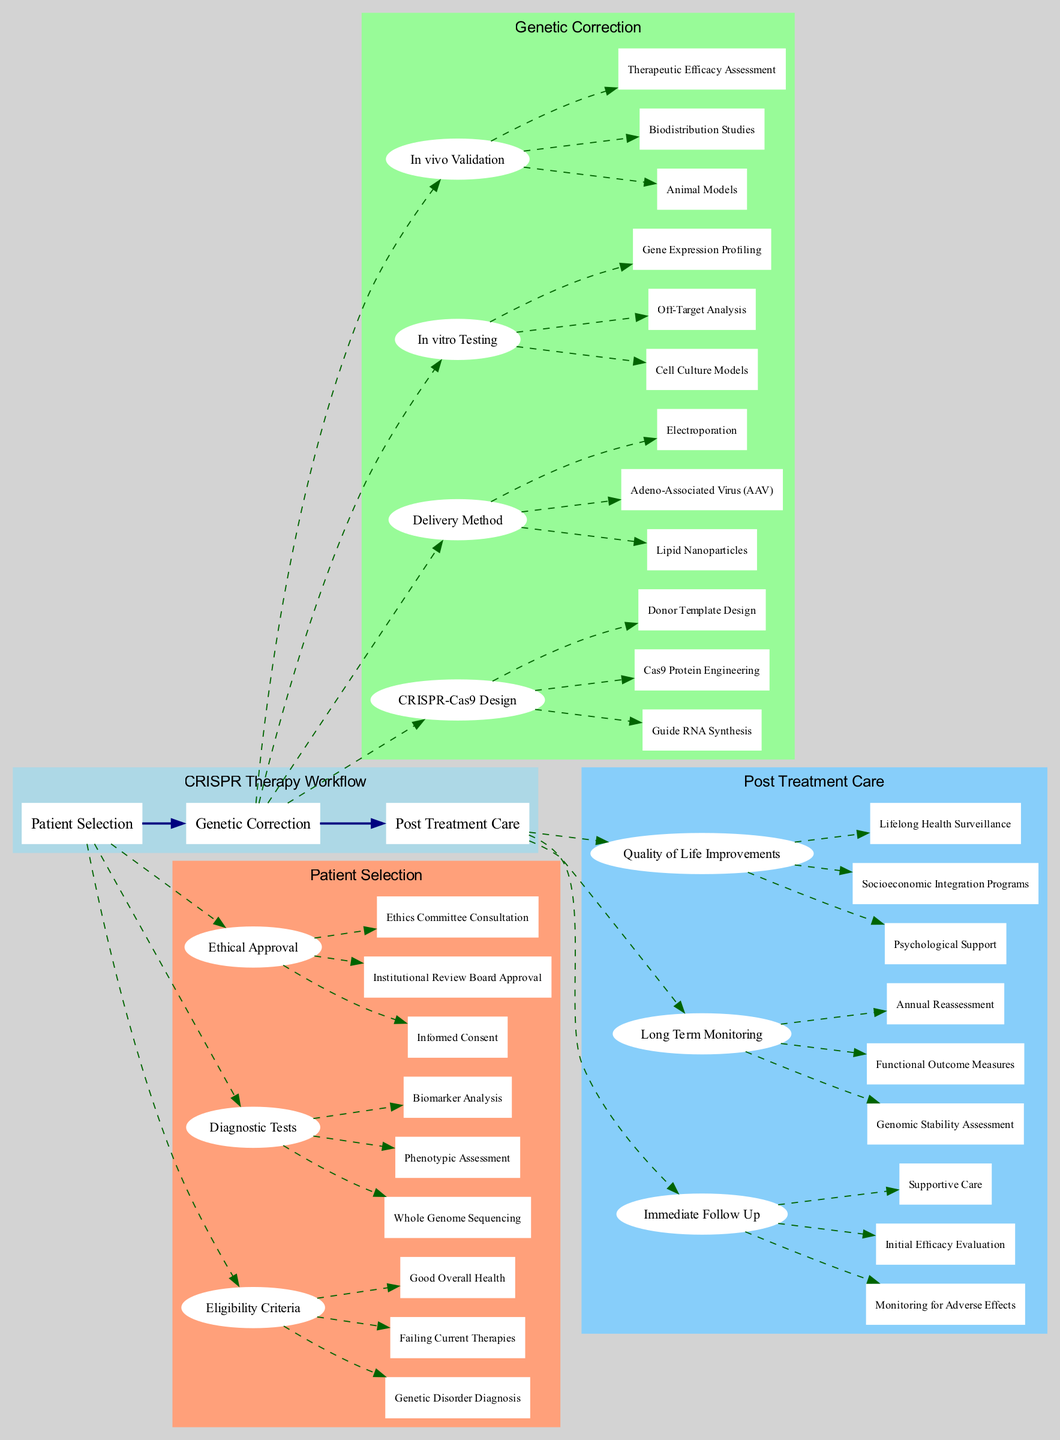What are the three eligibility criteria for patient selection? The diagram lists three eligibility criteria under Patient Selection: Genetic Disorder Diagnosis, Failing Current Therapies, and Good Overall Health.
Answer: Genetic Disorder Diagnosis, Failing Current Therapies, Good Overall Health How many delivery methods are there for genetic correction? There are three delivery methods listed under Genetic Correction: Lipid Nanoparticles, Adeno-Associated Virus, and Electroporation, making a total of three.
Answer: 3 What is the first item in post-treatment care? The diagram shows Immediate Follow-Up as the first category under Post Treatment Care, and the first item listed is Monitoring for Adverse Effects.
Answer: Monitoring for Adverse Effects What is the relationship between Ethical Approval and Patient Selection? The diagram clearly indicates that Ethical Approval is a sub-stage of Patient Selection, meaning that Ethical Approval is necessary for a patient to be selected for CRISPR therapy.
Answer: Ethical Approval is a sub-stage of Patient Selection What needs to be assessed in long-term monitoring? The diagram outlines Long Term Monitoring, which includes three aspects: Genomic Stability Assessment, Functional Outcome Measures, and Annual Reassessment.
Answer: Genomic Stability Assessment, Functional Outcome Measures, Annual Reassessment What are the two forms of in vivo validation mentioned? The diagram presents In vivo Validation as having three components; two of them are Animal Models and Therapeutic Efficacy Assessment.
Answer: Animal Models, Therapeutic Efficacy Assessment Which stage comes after genetic correction in the workflow? According to the flow of the diagram, Post Treatment Care follows after the Genetic Correction stage.
Answer: Post Treatment Care What is the main purpose of the CRISPR Therapy Workflow? The diagram generally illustrates the various stages and processes involved in the CRISPR therapy, which aim to provide a comprehensive pathway for treatment from patient selection to post-treatment care, indicating its purpose is to enhance therapeutic strategies using CRISPR technology.
Answer: Enhance therapeutic strategies using CRISPR technology 